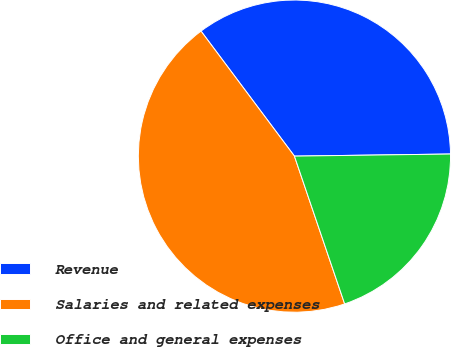<chart> <loc_0><loc_0><loc_500><loc_500><pie_chart><fcel>Revenue<fcel>Salaries and related expenses<fcel>Office and general expenses<nl><fcel>35.0%<fcel>45.0%<fcel>20.0%<nl></chart> 